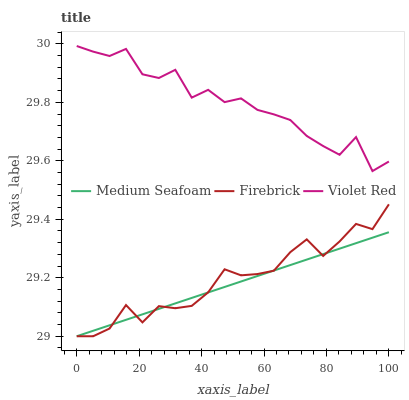Does Medium Seafoam have the minimum area under the curve?
Answer yes or no. Yes. Does Firebrick have the minimum area under the curve?
Answer yes or no. No. Does Firebrick have the maximum area under the curve?
Answer yes or no. No. Is Medium Seafoam the smoothest?
Answer yes or no. Yes. Is Violet Red the roughest?
Answer yes or no. Yes. Is Firebrick the smoothest?
Answer yes or no. No. Is Firebrick the roughest?
Answer yes or no. No. Does Firebrick have the highest value?
Answer yes or no. No. Is Medium Seafoam less than Violet Red?
Answer yes or no. Yes. Is Violet Red greater than Medium Seafoam?
Answer yes or no. Yes. Does Medium Seafoam intersect Violet Red?
Answer yes or no. No. 